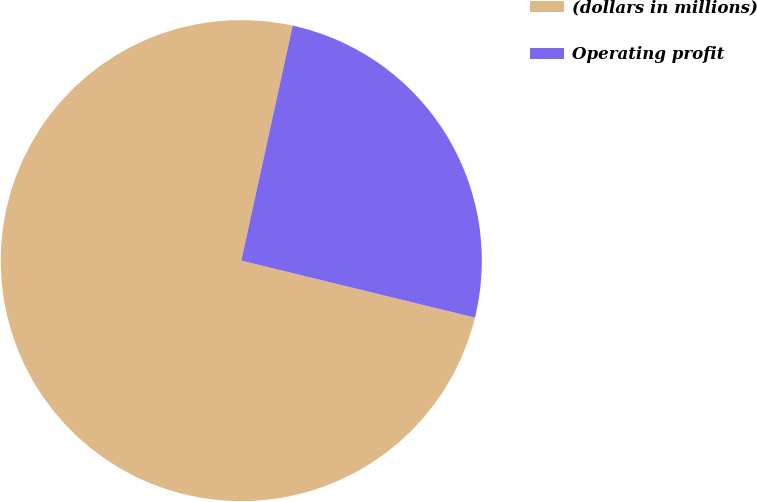Convert chart. <chart><loc_0><loc_0><loc_500><loc_500><pie_chart><fcel>(dollars in millions)<fcel>Operating profit<nl><fcel>74.62%<fcel>25.38%<nl></chart> 